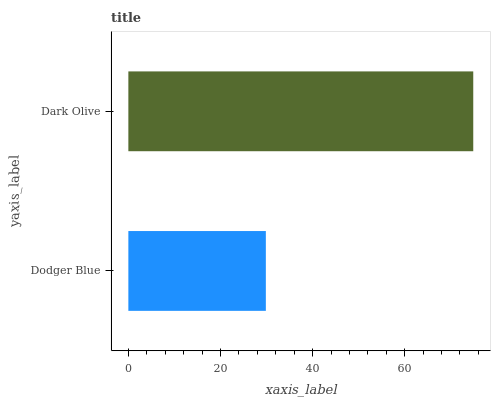Is Dodger Blue the minimum?
Answer yes or no. Yes. Is Dark Olive the maximum?
Answer yes or no. Yes. Is Dark Olive the minimum?
Answer yes or no. No. Is Dark Olive greater than Dodger Blue?
Answer yes or no. Yes. Is Dodger Blue less than Dark Olive?
Answer yes or no. Yes. Is Dodger Blue greater than Dark Olive?
Answer yes or no. No. Is Dark Olive less than Dodger Blue?
Answer yes or no. No. Is Dark Olive the high median?
Answer yes or no. Yes. Is Dodger Blue the low median?
Answer yes or no. Yes. Is Dodger Blue the high median?
Answer yes or no. No. Is Dark Olive the low median?
Answer yes or no. No. 